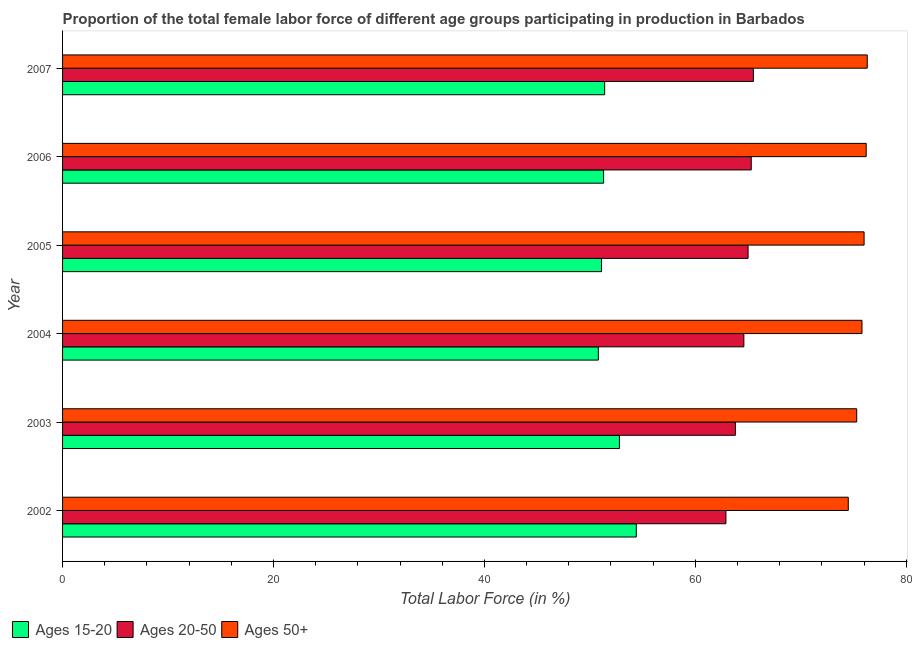How many bars are there on the 2nd tick from the top?
Provide a succinct answer. 3. How many bars are there on the 1st tick from the bottom?
Ensure brevity in your answer.  3. What is the percentage of female labor force within the age group 20-50 in 2005?
Your answer should be compact. 65. Across all years, what is the maximum percentage of female labor force within the age group 15-20?
Your answer should be very brief. 54.4. Across all years, what is the minimum percentage of female labor force above age 50?
Your response must be concise. 74.5. In which year was the percentage of female labor force above age 50 maximum?
Offer a very short reply. 2007. In which year was the percentage of female labor force within the age group 15-20 minimum?
Offer a very short reply. 2004. What is the total percentage of female labor force within the age group 20-50 in the graph?
Your response must be concise. 387.1. What is the difference between the percentage of female labor force above age 50 in 2006 and the percentage of female labor force within the age group 20-50 in 2002?
Offer a terse response. 13.3. What is the average percentage of female labor force above age 50 per year?
Keep it short and to the point. 75.68. In the year 2006, what is the difference between the percentage of female labor force within the age group 20-50 and percentage of female labor force within the age group 15-20?
Keep it short and to the point. 14. What is the difference between the highest and the second highest percentage of female labor force within the age group 15-20?
Your response must be concise. 1.6. What is the difference between the highest and the lowest percentage of female labor force above age 50?
Your response must be concise. 1.8. Is the sum of the percentage of female labor force within the age group 15-20 in 2003 and 2005 greater than the maximum percentage of female labor force within the age group 20-50 across all years?
Provide a succinct answer. Yes. What does the 1st bar from the top in 2002 represents?
Keep it short and to the point. Ages 50+. What does the 2nd bar from the bottom in 2004 represents?
Provide a short and direct response. Ages 20-50. How many years are there in the graph?
Offer a very short reply. 6. Are the values on the major ticks of X-axis written in scientific E-notation?
Offer a very short reply. No. Does the graph contain any zero values?
Provide a succinct answer. No. How many legend labels are there?
Make the answer very short. 3. How are the legend labels stacked?
Offer a very short reply. Horizontal. What is the title of the graph?
Offer a very short reply. Proportion of the total female labor force of different age groups participating in production in Barbados. Does "Coal sources" appear as one of the legend labels in the graph?
Your response must be concise. No. What is the label or title of the X-axis?
Provide a short and direct response. Total Labor Force (in %). What is the label or title of the Y-axis?
Give a very brief answer. Year. What is the Total Labor Force (in %) in Ages 15-20 in 2002?
Offer a terse response. 54.4. What is the Total Labor Force (in %) in Ages 20-50 in 2002?
Offer a very short reply. 62.9. What is the Total Labor Force (in %) of Ages 50+ in 2002?
Make the answer very short. 74.5. What is the Total Labor Force (in %) in Ages 15-20 in 2003?
Offer a very short reply. 52.8. What is the Total Labor Force (in %) of Ages 20-50 in 2003?
Keep it short and to the point. 63.8. What is the Total Labor Force (in %) of Ages 50+ in 2003?
Your response must be concise. 75.3. What is the Total Labor Force (in %) in Ages 15-20 in 2004?
Give a very brief answer. 50.8. What is the Total Labor Force (in %) of Ages 20-50 in 2004?
Keep it short and to the point. 64.6. What is the Total Labor Force (in %) of Ages 50+ in 2004?
Keep it short and to the point. 75.8. What is the Total Labor Force (in %) in Ages 15-20 in 2005?
Make the answer very short. 51.1. What is the Total Labor Force (in %) in Ages 50+ in 2005?
Give a very brief answer. 76. What is the Total Labor Force (in %) of Ages 15-20 in 2006?
Offer a terse response. 51.3. What is the Total Labor Force (in %) of Ages 20-50 in 2006?
Your response must be concise. 65.3. What is the Total Labor Force (in %) of Ages 50+ in 2006?
Provide a succinct answer. 76.2. What is the Total Labor Force (in %) in Ages 15-20 in 2007?
Your response must be concise. 51.4. What is the Total Labor Force (in %) in Ages 20-50 in 2007?
Your answer should be compact. 65.5. What is the Total Labor Force (in %) in Ages 50+ in 2007?
Keep it short and to the point. 76.3. Across all years, what is the maximum Total Labor Force (in %) of Ages 15-20?
Your answer should be compact. 54.4. Across all years, what is the maximum Total Labor Force (in %) in Ages 20-50?
Provide a succinct answer. 65.5. Across all years, what is the maximum Total Labor Force (in %) in Ages 50+?
Offer a terse response. 76.3. Across all years, what is the minimum Total Labor Force (in %) of Ages 15-20?
Ensure brevity in your answer.  50.8. Across all years, what is the minimum Total Labor Force (in %) in Ages 20-50?
Your answer should be compact. 62.9. Across all years, what is the minimum Total Labor Force (in %) of Ages 50+?
Provide a succinct answer. 74.5. What is the total Total Labor Force (in %) in Ages 15-20 in the graph?
Ensure brevity in your answer.  311.8. What is the total Total Labor Force (in %) of Ages 20-50 in the graph?
Your response must be concise. 387.1. What is the total Total Labor Force (in %) of Ages 50+ in the graph?
Your response must be concise. 454.1. What is the difference between the Total Labor Force (in %) in Ages 50+ in 2002 and that in 2003?
Your response must be concise. -0.8. What is the difference between the Total Labor Force (in %) of Ages 15-20 in 2002 and that in 2004?
Give a very brief answer. 3.6. What is the difference between the Total Labor Force (in %) of Ages 20-50 in 2002 and that in 2005?
Ensure brevity in your answer.  -2.1. What is the difference between the Total Labor Force (in %) in Ages 15-20 in 2002 and that in 2006?
Your response must be concise. 3.1. What is the difference between the Total Labor Force (in %) in Ages 15-20 in 2003 and that in 2004?
Give a very brief answer. 2. What is the difference between the Total Labor Force (in %) of Ages 20-50 in 2003 and that in 2005?
Give a very brief answer. -1.2. What is the difference between the Total Labor Force (in %) of Ages 20-50 in 2003 and that in 2006?
Give a very brief answer. -1.5. What is the difference between the Total Labor Force (in %) in Ages 50+ in 2003 and that in 2006?
Make the answer very short. -0.9. What is the difference between the Total Labor Force (in %) in Ages 15-20 in 2004 and that in 2005?
Offer a very short reply. -0.3. What is the difference between the Total Labor Force (in %) of Ages 20-50 in 2004 and that in 2005?
Provide a short and direct response. -0.4. What is the difference between the Total Labor Force (in %) of Ages 15-20 in 2004 and that in 2006?
Keep it short and to the point. -0.5. What is the difference between the Total Labor Force (in %) of Ages 15-20 in 2004 and that in 2007?
Provide a succinct answer. -0.6. What is the difference between the Total Labor Force (in %) of Ages 20-50 in 2004 and that in 2007?
Provide a short and direct response. -0.9. What is the difference between the Total Labor Force (in %) in Ages 50+ in 2004 and that in 2007?
Your answer should be compact. -0.5. What is the difference between the Total Labor Force (in %) of Ages 15-20 in 2005 and that in 2006?
Keep it short and to the point. -0.2. What is the difference between the Total Labor Force (in %) of Ages 20-50 in 2005 and that in 2006?
Give a very brief answer. -0.3. What is the difference between the Total Labor Force (in %) of Ages 15-20 in 2005 and that in 2007?
Ensure brevity in your answer.  -0.3. What is the difference between the Total Labor Force (in %) of Ages 20-50 in 2005 and that in 2007?
Your answer should be compact. -0.5. What is the difference between the Total Labor Force (in %) of Ages 50+ in 2005 and that in 2007?
Your answer should be compact. -0.3. What is the difference between the Total Labor Force (in %) of Ages 15-20 in 2002 and the Total Labor Force (in %) of Ages 20-50 in 2003?
Keep it short and to the point. -9.4. What is the difference between the Total Labor Force (in %) of Ages 15-20 in 2002 and the Total Labor Force (in %) of Ages 50+ in 2003?
Offer a very short reply. -20.9. What is the difference between the Total Labor Force (in %) of Ages 15-20 in 2002 and the Total Labor Force (in %) of Ages 50+ in 2004?
Offer a terse response. -21.4. What is the difference between the Total Labor Force (in %) in Ages 15-20 in 2002 and the Total Labor Force (in %) in Ages 50+ in 2005?
Offer a terse response. -21.6. What is the difference between the Total Labor Force (in %) in Ages 15-20 in 2002 and the Total Labor Force (in %) in Ages 50+ in 2006?
Provide a short and direct response. -21.8. What is the difference between the Total Labor Force (in %) of Ages 20-50 in 2002 and the Total Labor Force (in %) of Ages 50+ in 2006?
Provide a short and direct response. -13.3. What is the difference between the Total Labor Force (in %) in Ages 15-20 in 2002 and the Total Labor Force (in %) in Ages 20-50 in 2007?
Your answer should be compact. -11.1. What is the difference between the Total Labor Force (in %) in Ages 15-20 in 2002 and the Total Labor Force (in %) in Ages 50+ in 2007?
Provide a short and direct response. -21.9. What is the difference between the Total Labor Force (in %) of Ages 20-50 in 2002 and the Total Labor Force (in %) of Ages 50+ in 2007?
Ensure brevity in your answer.  -13.4. What is the difference between the Total Labor Force (in %) in Ages 15-20 in 2003 and the Total Labor Force (in %) in Ages 50+ in 2005?
Ensure brevity in your answer.  -23.2. What is the difference between the Total Labor Force (in %) in Ages 15-20 in 2003 and the Total Labor Force (in %) in Ages 20-50 in 2006?
Make the answer very short. -12.5. What is the difference between the Total Labor Force (in %) in Ages 15-20 in 2003 and the Total Labor Force (in %) in Ages 50+ in 2006?
Provide a succinct answer. -23.4. What is the difference between the Total Labor Force (in %) in Ages 15-20 in 2003 and the Total Labor Force (in %) in Ages 20-50 in 2007?
Keep it short and to the point. -12.7. What is the difference between the Total Labor Force (in %) of Ages 15-20 in 2003 and the Total Labor Force (in %) of Ages 50+ in 2007?
Your answer should be compact. -23.5. What is the difference between the Total Labor Force (in %) in Ages 20-50 in 2003 and the Total Labor Force (in %) in Ages 50+ in 2007?
Give a very brief answer. -12.5. What is the difference between the Total Labor Force (in %) of Ages 15-20 in 2004 and the Total Labor Force (in %) of Ages 20-50 in 2005?
Provide a succinct answer. -14.2. What is the difference between the Total Labor Force (in %) in Ages 15-20 in 2004 and the Total Labor Force (in %) in Ages 50+ in 2005?
Your answer should be compact. -25.2. What is the difference between the Total Labor Force (in %) in Ages 15-20 in 2004 and the Total Labor Force (in %) in Ages 50+ in 2006?
Keep it short and to the point. -25.4. What is the difference between the Total Labor Force (in %) in Ages 15-20 in 2004 and the Total Labor Force (in %) in Ages 20-50 in 2007?
Provide a succinct answer. -14.7. What is the difference between the Total Labor Force (in %) in Ages 15-20 in 2004 and the Total Labor Force (in %) in Ages 50+ in 2007?
Keep it short and to the point. -25.5. What is the difference between the Total Labor Force (in %) in Ages 15-20 in 2005 and the Total Labor Force (in %) in Ages 50+ in 2006?
Provide a succinct answer. -25.1. What is the difference between the Total Labor Force (in %) in Ages 15-20 in 2005 and the Total Labor Force (in %) in Ages 20-50 in 2007?
Provide a short and direct response. -14.4. What is the difference between the Total Labor Force (in %) in Ages 15-20 in 2005 and the Total Labor Force (in %) in Ages 50+ in 2007?
Your answer should be very brief. -25.2. What is the difference between the Total Labor Force (in %) in Ages 15-20 in 2006 and the Total Labor Force (in %) in Ages 50+ in 2007?
Your response must be concise. -25. What is the average Total Labor Force (in %) in Ages 15-20 per year?
Offer a terse response. 51.97. What is the average Total Labor Force (in %) of Ages 20-50 per year?
Offer a terse response. 64.52. What is the average Total Labor Force (in %) of Ages 50+ per year?
Your response must be concise. 75.68. In the year 2002, what is the difference between the Total Labor Force (in %) of Ages 15-20 and Total Labor Force (in %) of Ages 20-50?
Give a very brief answer. -8.5. In the year 2002, what is the difference between the Total Labor Force (in %) of Ages 15-20 and Total Labor Force (in %) of Ages 50+?
Your response must be concise. -20.1. In the year 2002, what is the difference between the Total Labor Force (in %) of Ages 20-50 and Total Labor Force (in %) of Ages 50+?
Offer a very short reply. -11.6. In the year 2003, what is the difference between the Total Labor Force (in %) in Ages 15-20 and Total Labor Force (in %) in Ages 20-50?
Give a very brief answer. -11. In the year 2003, what is the difference between the Total Labor Force (in %) of Ages 15-20 and Total Labor Force (in %) of Ages 50+?
Provide a short and direct response. -22.5. In the year 2004, what is the difference between the Total Labor Force (in %) in Ages 15-20 and Total Labor Force (in %) in Ages 20-50?
Provide a short and direct response. -13.8. In the year 2004, what is the difference between the Total Labor Force (in %) of Ages 15-20 and Total Labor Force (in %) of Ages 50+?
Your answer should be compact. -25. In the year 2005, what is the difference between the Total Labor Force (in %) of Ages 15-20 and Total Labor Force (in %) of Ages 20-50?
Make the answer very short. -13.9. In the year 2005, what is the difference between the Total Labor Force (in %) in Ages 15-20 and Total Labor Force (in %) in Ages 50+?
Ensure brevity in your answer.  -24.9. In the year 2006, what is the difference between the Total Labor Force (in %) of Ages 15-20 and Total Labor Force (in %) of Ages 50+?
Offer a very short reply. -24.9. In the year 2006, what is the difference between the Total Labor Force (in %) in Ages 20-50 and Total Labor Force (in %) in Ages 50+?
Your answer should be compact. -10.9. In the year 2007, what is the difference between the Total Labor Force (in %) in Ages 15-20 and Total Labor Force (in %) in Ages 20-50?
Your answer should be very brief. -14.1. In the year 2007, what is the difference between the Total Labor Force (in %) in Ages 15-20 and Total Labor Force (in %) in Ages 50+?
Your response must be concise. -24.9. In the year 2007, what is the difference between the Total Labor Force (in %) of Ages 20-50 and Total Labor Force (in %) of Ages 50+?
Make the answer very short. -10.8. What is the ratio of the Total Labor Force (in %) in Ages 15-20 in 2002 to that in 2003?
Provide a short and direct response. 1.03. What is the ratio of the Total Labor Force (in %) of Ages 20-50 in 2002 to that in 2003?
Provide a succinct answer. 0.99. What is the ratio of the Total Labor Force (in %) in Ages 15-20 in 2002 to that in 2004?
Your answer should be very brief. 1.07. What is the ratio of the Total Labor Force (in %) in Ages 20-50 in 2002 to that in 2004?
Provide a succinct answer. 0.97. What is the ratio of the Total Labor Force (in %) in Ages 50+ in 2002 to that in 2004?
Provide a short and direct response. 0.98. What is the ratio of the Total Labor Force (in %) in Ages 15-20 in 2002 to that in 2005?
Make the answer very short. 1.06. What is the ratio of the Total Labor Force (in %) of Ages 50+ in 2002 to that in 2005?
Ensure brevity in your answer.  0.98. What is the ratio of the Total Labor Force (in %) in Ages 15-20 in 2002 to that in 2006?
Offer a terse response. 1.06. What is the ratio of the Total Labor Force (in %) of Ages 20-50 in 2002 to that in 2006?
Your response must be concise. 0.96. What is the ratio of the Total Labor Force (in %) of Ages 50+ in 2002 to that in 2006?
Make the answer very short. 0.98. What is the ratio of the Total Labor Force (in %) of Ages 15-20 in 2002 to that in 2007?
Provide a succinct answer. 1.06. What is the ratio of the Total Labor Force (in %) of Ages 20-50 in 2002 to that in 2007?
Your response must be concise. 0.96. What is the ratio of the Total Labor Force (in %) in Ages 50+ in 2002 to that in 2007?
Ensure brevity in your answer.  0.98. What is the ratio of the Total Labor Force (in %) of Ages 15-20 in 2003 to that in 2004?
Your response must be concise. 1.04. What is the ratio of the Total Labor Force (in %) in Ages 20-50 in 2003 to that in 2004?
Offer a terse response. 0.99. What is the ratio of the Total Labor Force (in %) of Ages 50+ in 2003 to that in 2004?
Offer a very short reply. 0.99. What is the ratio of the Total Labor Force (in %) of Ages 15-20 in 2003 to that in 2005?
Offer a very short reply. 1.03. What is the ratio of the Total Labor Force (in %) of Ages 20-50 in 2003 to that in 2005?
Your answer should be compact. 0.98. What is the ratio of the Total Labor Force (in %) of Ages 15-20 in 2003 to that in 2006?
Offer a terse response. 1.03. What is the ratio of the Total Labor Force (in %) in Ages 20-50 in 2003 to that in 2006?
Keep it short and to the point. 0.98. What is the ratio of the Total Labor Force (in %) in Ages 15-20 in 2003 to that in 2007?
Make the answer very short. 1.03. What is the ratio of the Total Labor Force (in %) in Ages 20-50 in 2003 to that in 2007?
Provide a succinct answer. 0.97. What is the ratio of the Total Labor Force (in %) of Ages 50+ in 2003 to that in 2007?
Make the answer very short. 0.99. What is the ratio of the Total Labor Force (in %) of Ages 15-20 in 2004 to that in 2005?
Offer a terse response. 0.99. What is the ratio of the Total Labor Force (in %) of Ages 50+ in 2004 to that in 2005?
Make the answer very short. 1. What is the ratio of the Total Labor Force (in %) in Ages 15-20 in 2004 to that in 2006?
Provide a short and direct response. 0.99. What is the ratio of the Total Labor Force (in %) in Ages 20-50 in 2004 to that in 2006?
Your response must be concise. 0.99. What is the ratio of the Total Labor Force (in %) of Ages 50+ in 2004 to that in 2006?
Give a very brief answer. 0.99. What is the ratio of the Total Labor Force (in %) of Ages 15-20 in 2004 to that in 2007?
Offer a terse response. 0.99. What is the ratio of the Total Labor Force (in %) of Ages 20-50 in 2004 to that in 2007?
Give a very brief answer. 0.99. What is the ratio of the Total Labor Force (in %) in Ages 20-50 in 2005 to that in 2006?
Provide a short and direct response. 1. What is the ratio of the Total Labor Force (in %) in Ages 15-20 in 2005 to that in 2007?
Your answer should be very brief. 0.99. What is the ratio of the Total Labor Force (in %) in Ages 50+ in 2005 to that in 2007?
Make the answer very short. 1. What is the ratio of the Total Labor Force (in %) of Ages 15-20 in 2006 to that in 2007?
Provide a short and direct response. 1. What is the ratio of the Total Labor Force (in %) in Ages 50+ in 2006 to that in 2007?
Offer a terse response. 1. What is the difference between the highest and the second highest Total Labor Force (in %) of Ages 15-20?
Your response must be concise. 1.6. What is the difference between the highest and the second highest Total Labor Force (in %) in Ages 50+?
Give a very brief answer. 0.1. What is the difference between the highest and the lowest Total Labor Force (in %) in Ages 20-50?
Keep it short and to the point. 2.6. What is the difference between the highest and the lowest Total Labor Force (in %) in Ages 50+?
Keep it short and to the point. 1.8. 